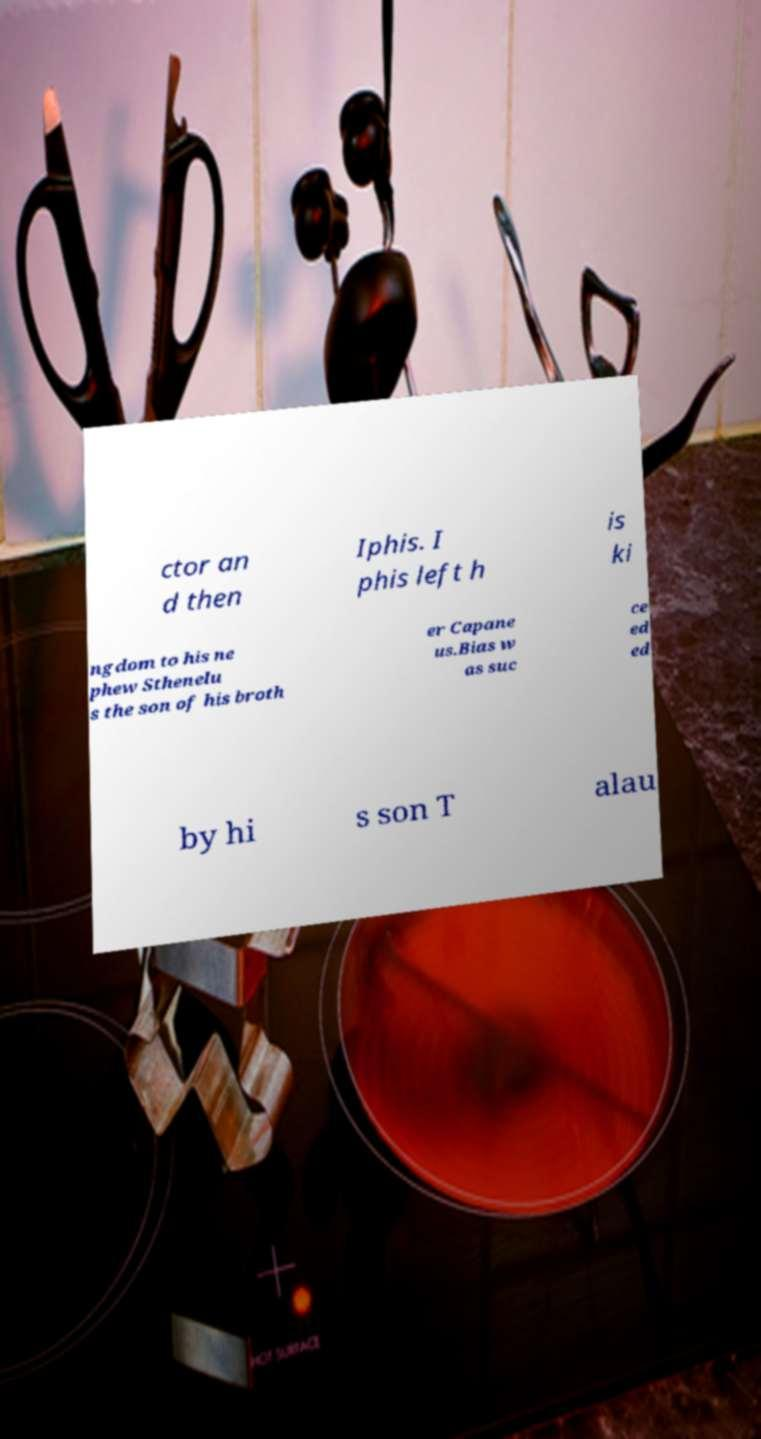Please identify and transcribe the text found in this image. ctor an d then Iphis. I phis left h is ki ngdom to his ne phew Sthenelu s the son of his broth er Capane us.Bias w as suc ce ed ed by hi s son T alau 